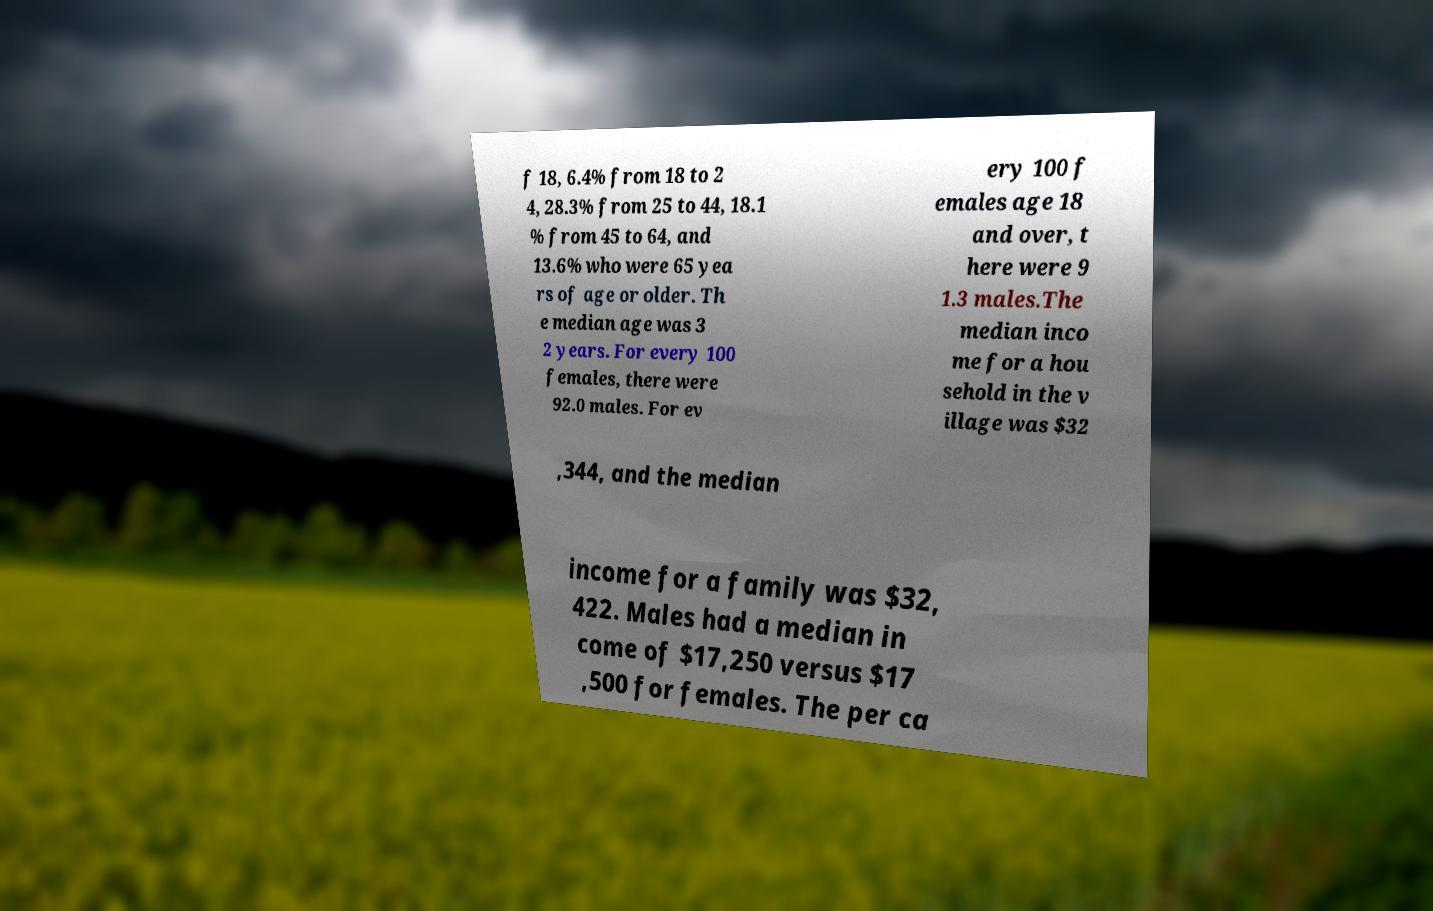There's text embedded in this image that I need extracted. Can you transcribe it verbatim? f 18, 6.4% from 18 to 2 4, 28.3% from 25 to 44, 18.1 % from 45 to 64, and 13.6% who were 65 yea rs of age or older. Th e median age was 3 2 years. For every 100 females, there were 92.0 males. For ev ery 100 f emales age 18 and over, t here were 9 1.3 males.The median inco me for a hou sehold in the v illage was $32 ,344, and the median income for a family was $32, 422. Males had a median in come of $17,250 versus $17 ,500 for females. The per ca 